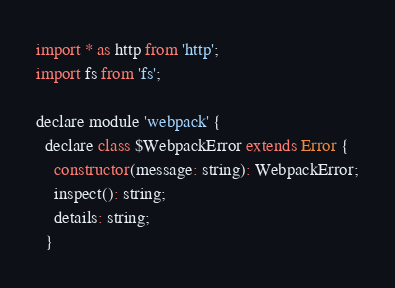<code> <loc_0><loc_0><loc_500><loc_500><_JavaScript_>import * as http from 'http';
import fs from 'fs';

declare module 'webpack' {
  declare class $WebpackError extends Error {
    constructor(message: string): WebpackError;
    inspect(): string;
    details: string;
  }
</code> 